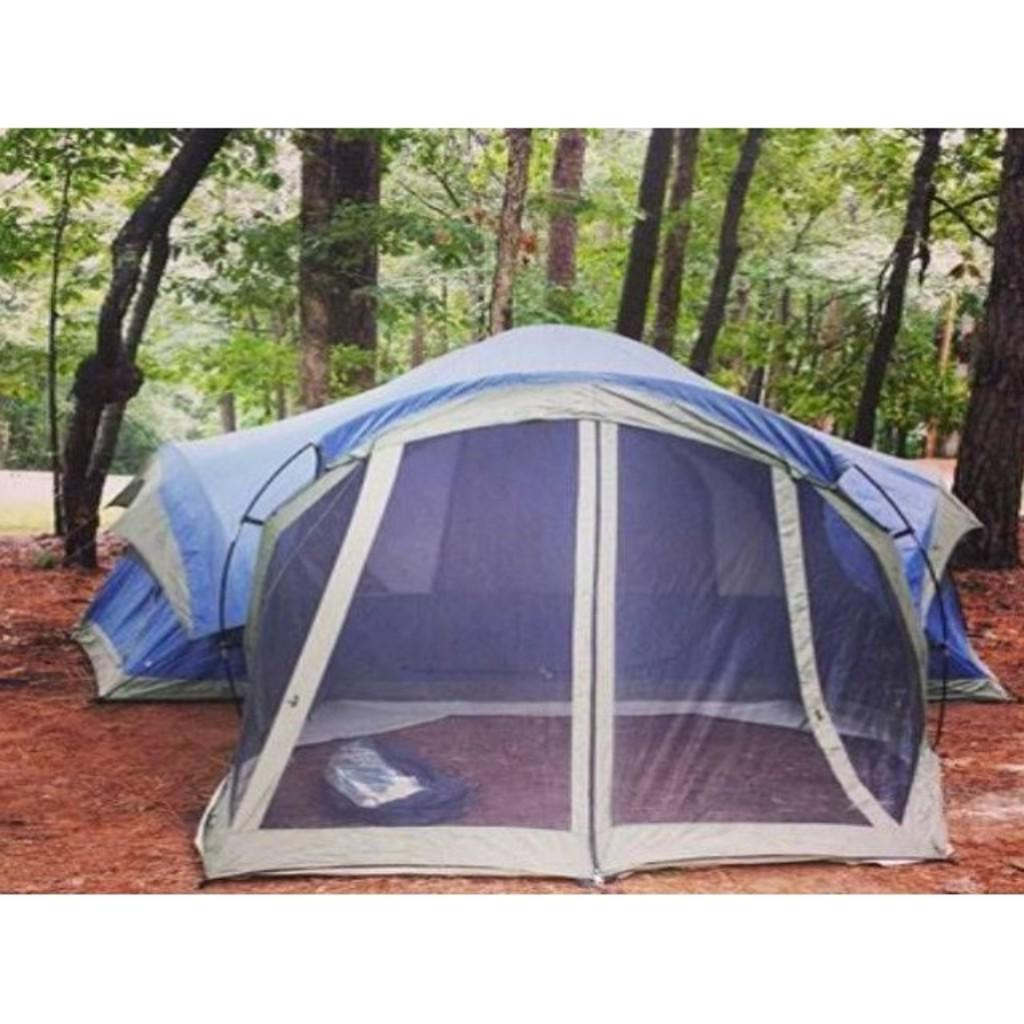What type of temporary shelter is visible in the image? There are tents in the image. What is located on the ground near the tents? There is a backpack on the ground in the image. What type of natural vegetation can be seen in the image? There are trees visible in the image. What type of farming equipment is visible in the image? There is no farming equipment present in the image. What type of material is the minister wearing in the image? There is no minister present in the image. 